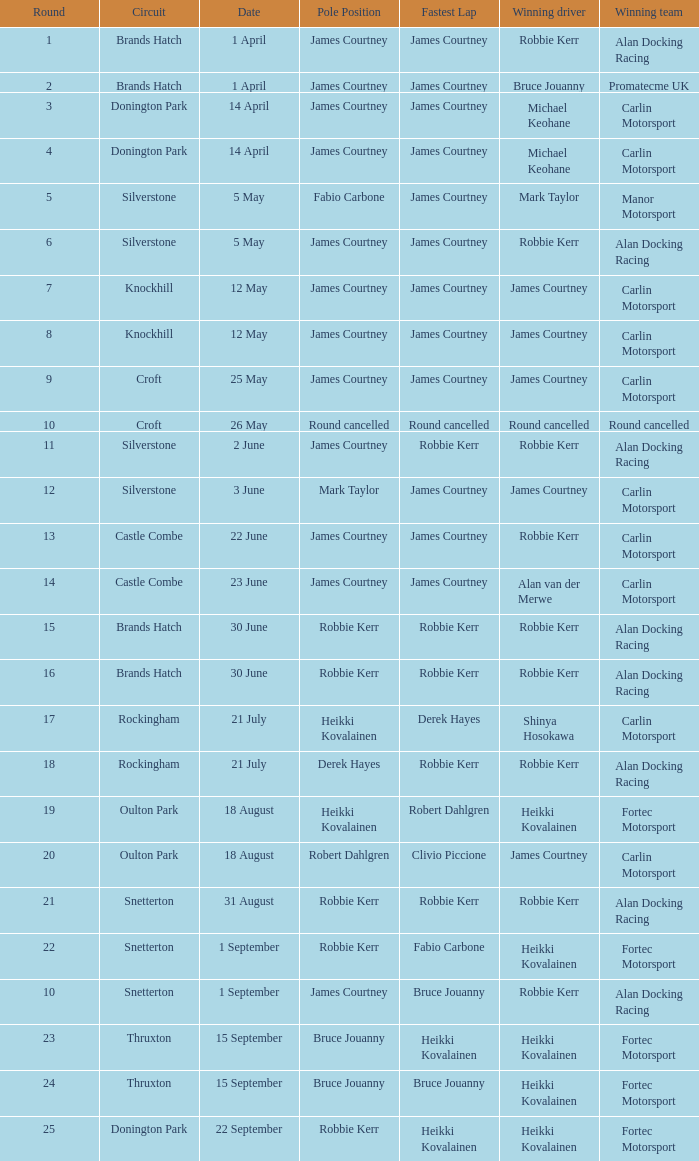For the castle combe circuit, what are the pole positions in which robbie kerr has been the victorious driver? James Courtney. 